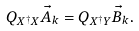Convert formula to latex. <formula><loc_0><loc_0><loc_500><loc_500>Q _ { X ^ { \dagger } X } \vec { A } _ { k } = Q _ { X ^ { \dagger } Y } \vec { B } _ { k } .</formula> 